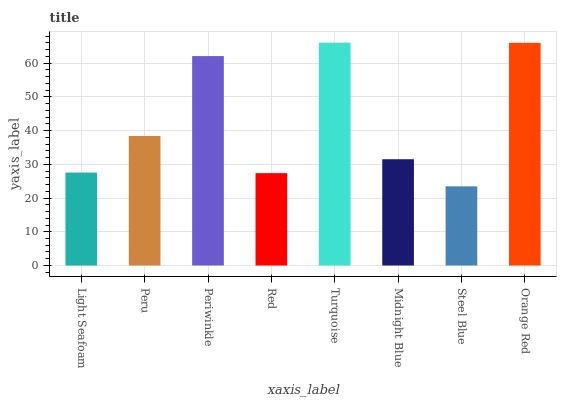Is Peru the minimum?
Answer yes or no. No. Is Peru the maximum?
Answer yes or no. No. Is Peru greater than Light Seafoam?
Answer yes or no. Yes. Is Light Seafoam less than Peru?
Answer yes or no. Yes. Is Light Seafoam greater than Peru?
Answer yes or no. No. Is Peru less than Light Seafoam?
Answer yes or no. No. Is Peru the high median?
Answer yes or no. Yes. Is Midnight Blue the low median?
Answer yes or no. Yes. Is Red the high median?
Answer yes or no. No. Is Turquoise the low median?
Answer yes or no. No. 